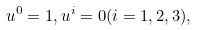Convert formula to latex. <formula><loc_0><loc_0><loc_500><loc_500>u ^ { 0 } = 1 , u ^ { i } = 0 ( i = 1 , 2 , 3 ) ,</formula> 